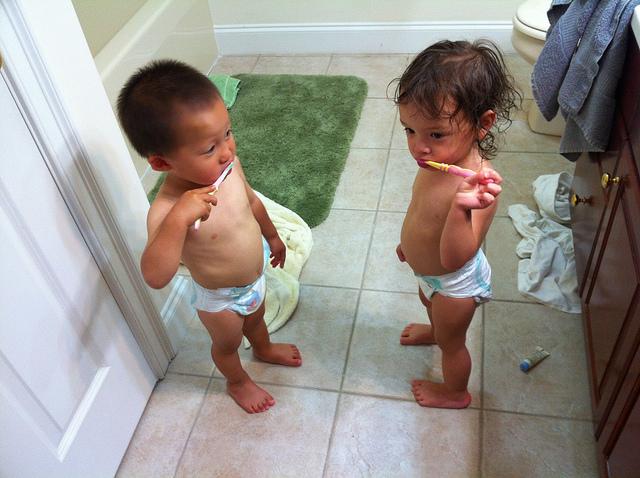Are they brushing their teeth?
Be succinct. Yes. Are these twins?
Quick response, please. No. How many of these people's feet are on the ground?
Answer briefly. 2. Are these people over age 14?
Quick response, please. No. 